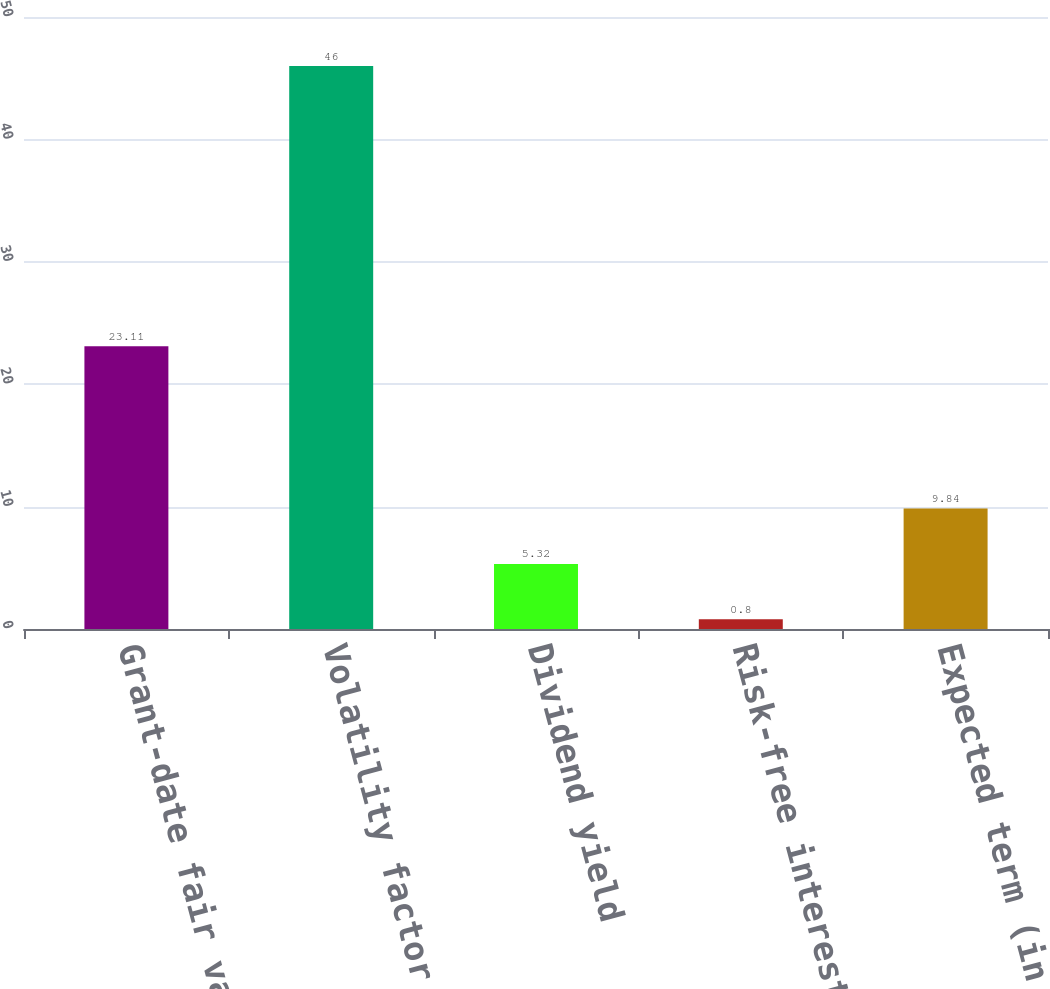Convert chart to OTSL. <chart><loc_0><loc_0><loc_500><loc_500><bar_chart><fcel>Grant-date fair value<fcel>Volatility factor<fcel>Dividend yield<fcel>Risk-free interest rate<fcel>Expected term (in years)<nl><fcel>23.11<fcel>46<fcel>5.32<fcel>0.8<fcel>9.84<nl></chart> 